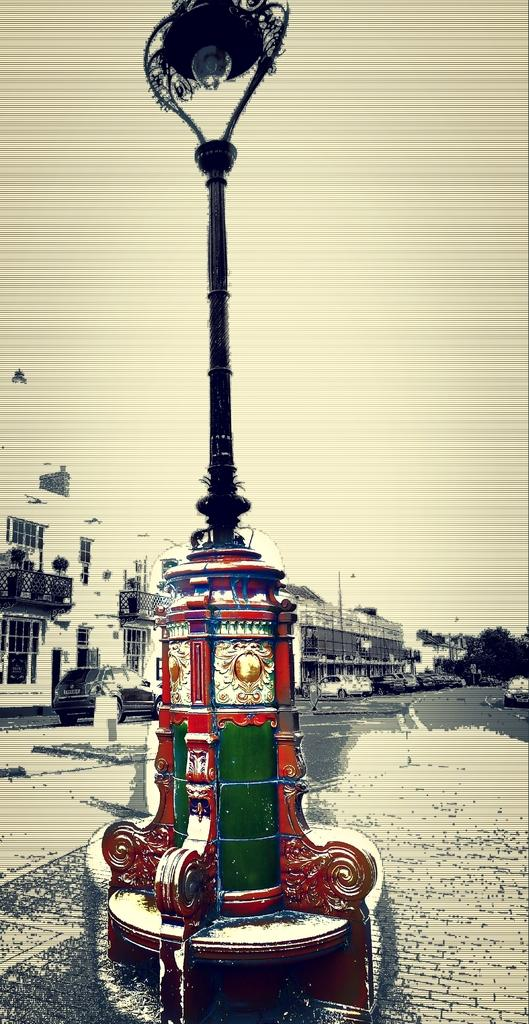What is attached to the pole in the image? There is a light attached to the pole in the image. What can be seen in the distance behind the pole? There are buildings in the background of the image. What is moving on the road in the image? Vehicles are present on the road in the image. What type of vegetation is visible in the image? Plants and trees are visible in the image. What type of impulse can be seen affecting the sister in the image? There is no sister or impulse present in the image. What type of fan is visible in the image? There is no fan present in the image. 